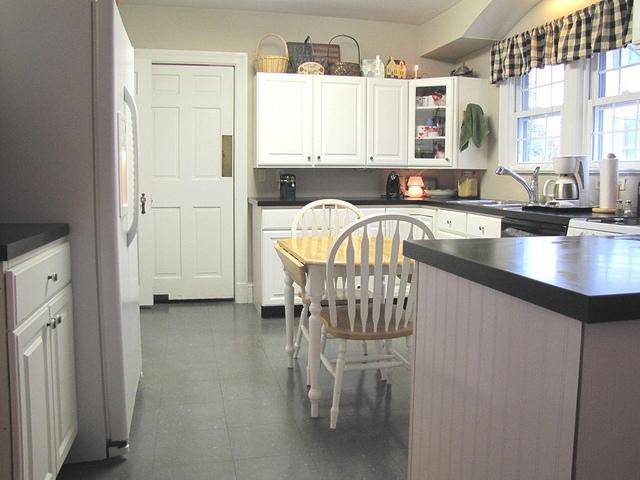Is there a paper towel roll on the counter?
Answer briefly. Yes. Are people getting ready to eat at the table?
Give a very brief answer. No. Are the counters clean?
Quick response, please. Yes. 